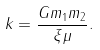<formula> <loc_0><loc_0><loc_500><loc_500>k = \frac { G m _ { 1 } m _ { 2 } } { \xi \mu } .</formula> 